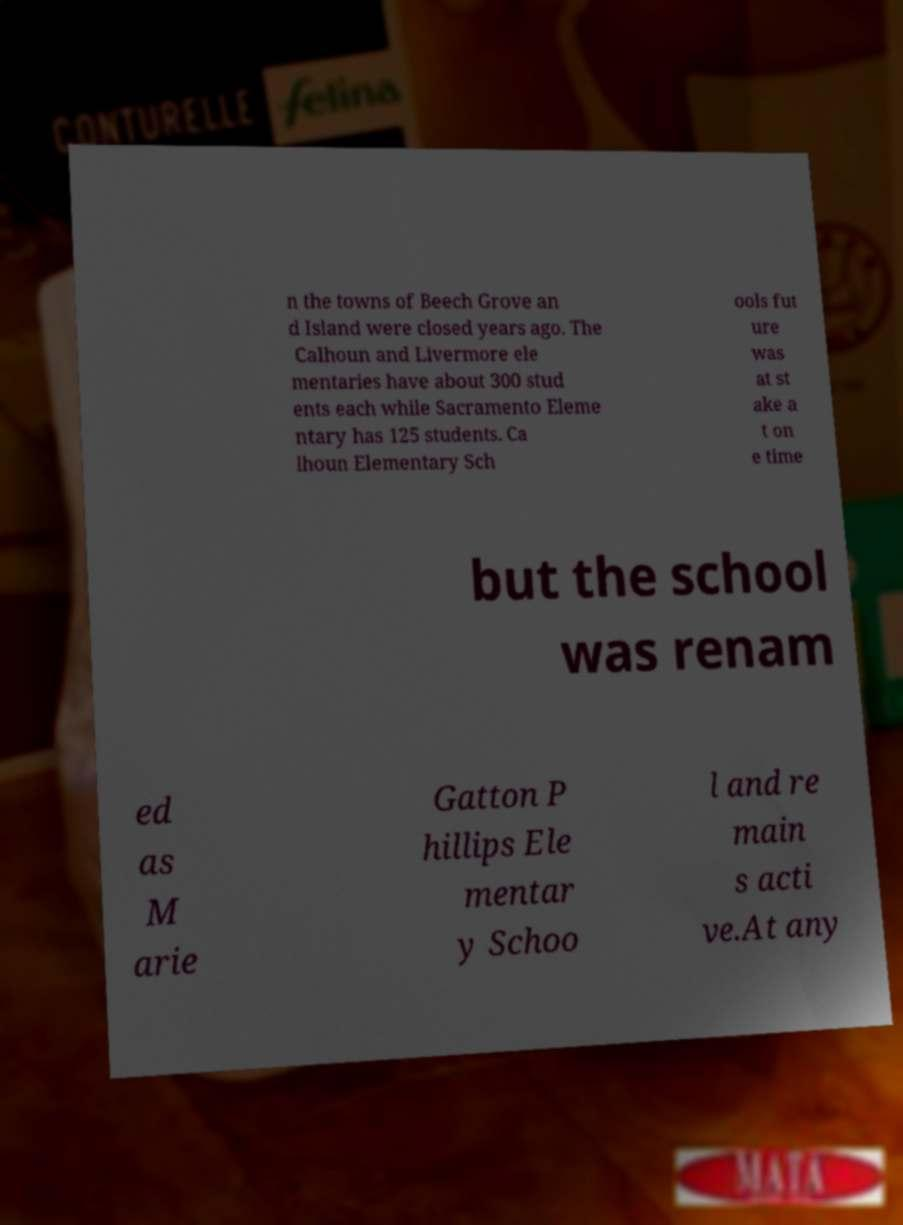Can you accurately transcribe the text from the provided image for me? n the towns of Beech Grove an d Island were closed years ago. The Calhoun and Livermore ele mentaries have about 300 stud ents each while Sacramento Eleme ntary has 125 students. Ca lhoun Elementary Sch ools fut ure was at st ake a t on e time but the school was renam ed as M arie Gatton P hillips Ele mentar y Schoo l and re main s acti ve.At any 